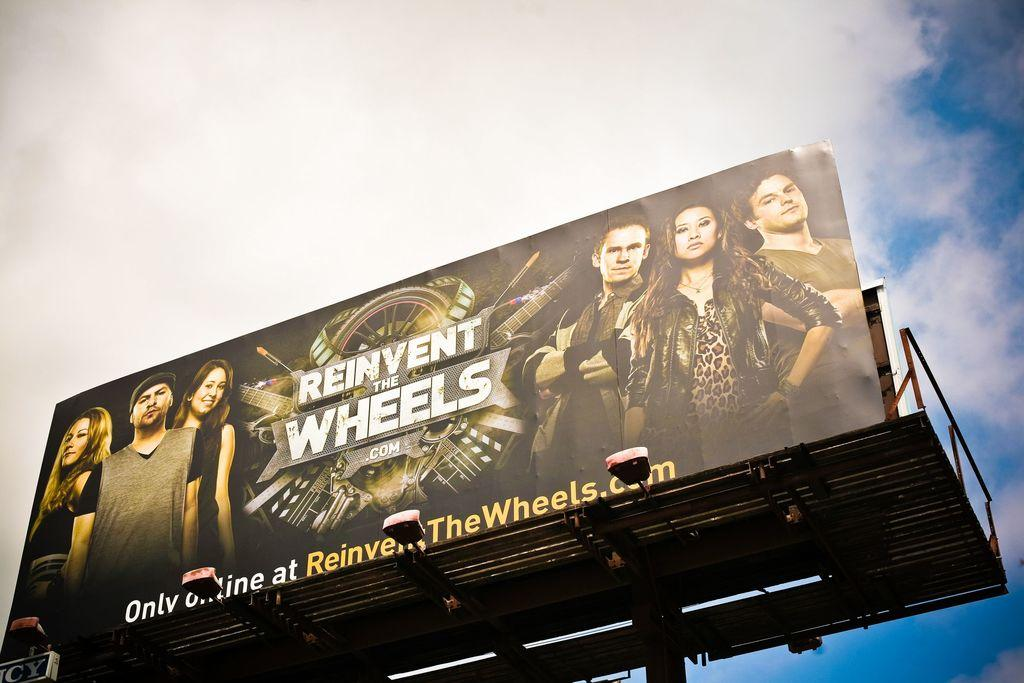<image>
Relay a brief, clear account of the picture shown. A logo with reinvent the wheels that is only online 